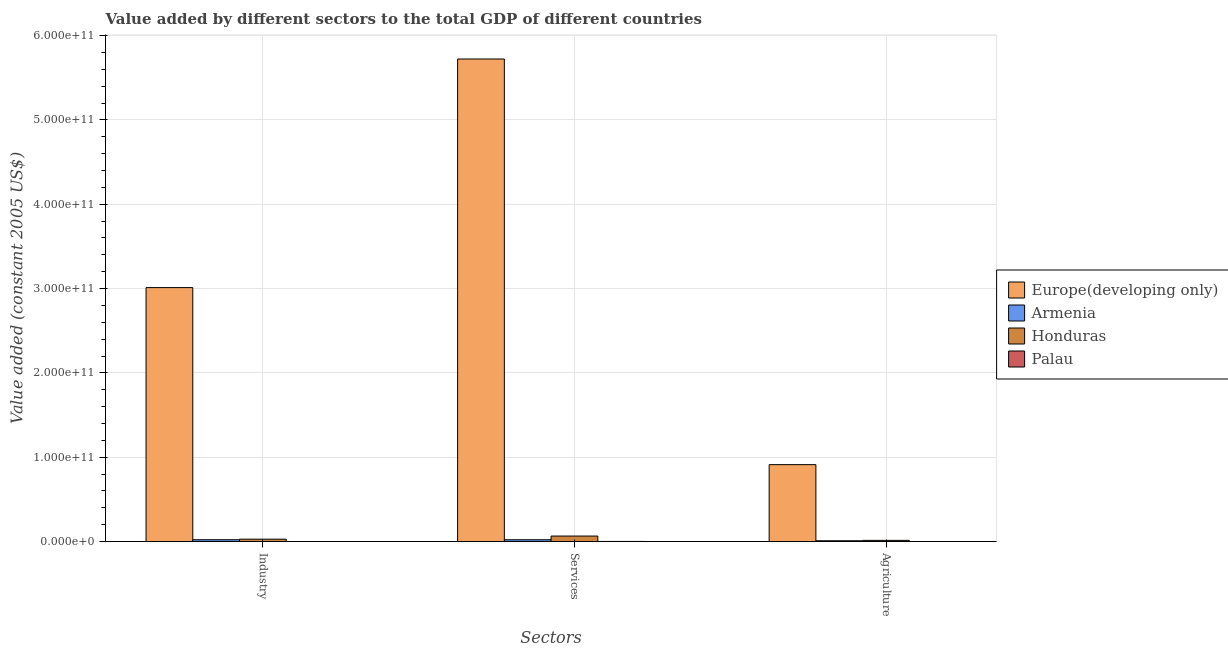How many different coloured bars are there?
Make the answer very short. 4. Are the number of bars on each tick of the X-axis equal?
Offer a very short reply. Yes. How many bars are there on the 2nd tick from the left?
Your answer should be compact. 4. What is the label of the 3rd group of bars from the left?
Your answer should be compact. Agriculture. What is the value added by agricultural sector in Europe(developing only)?
Provide a succinct answer. 9.12e+1. Across all countries, what is the maximum value added by services?
Your answer should be compact. 5.72e+11. Across all countries, what is the minimum value added by services?
Your response must be concise. 1.30e+08. In which country was the value added by services maximum?
Ensure brevity in your answer.  Europe(developing only). In which country was the value added by industrial sector minimum?
Your response must be concise. Palau. What is the total value added by agricultural sector in the graph?
Keep it short and to the point. 9.36e+1. What is the difference between the value added by agricultural sector in Armenia and that in Honduras?
Make the answer very short. -4.41e+08. What is the difference between the value added by agricultural sector in Europe(developing only) and the value added by services in Honduras?
Your answer should be compact. 8.47e+1. What is the average value added by agricultural sector per country?
Keep it short and to the point. 2.34e+1. What is the difference between the value added by services and value added by industrial sector in Honduras?
Give a very brief answer. 3.71e+09. In how many countries, is the value added by services greater than 80000000000 US$?
Provide a succinct answer. 1. What is the ratio of the value added by services in Honduras to that in Palau?
Provide a succinct answer. 50.4. Is the value added by agricultural sector in Armenia less than that in Palau?
Offer a terse response. No. Is the difference between the value added by industrial sector in Honduras and Palau greater than the difference between the value added by agricultural sector in Honduras and Palau?
Provide a short and direct response. Yes. What is the difference between the highest and the second highest value added by services?
Provide a succinct answer. 5.66e+11. What is the difference between the highest and the lowest value added by agricultural sector?
Your response must be concise. 9.12e+1. In how many countries, is the value added by industrial sector greater than the average value added by industrial sector taken over all countries?
Offer a very short reply. 1. What does the 3rd bar from the left in Industry represents?
Make the answer very short. Honduras. What does the 2nd bar from the right in Industry represents?
Your response must be concise. Honduras. Is it the case that in every country, the sum of the value added by industrial sector and value added by services is greater than the value added by agricultural sector?
Make the answer very short. Yes. Are all the bars in the graph horizontal?
Provide a succinct answer. No. How many countries are there in the graph?
Provide a succinct answer. 4. What is the difference between two consecutive major ticks on the Y-axis?
Ensure brevity in your answer.  1.00e+11. Are the values on the major ticks of Y-axis written in scientific E-notation?
Offer a terse response. Yes. Does the graph contain any zero values?
Provide a short and direct response. No. Where does the legend appear in the graph?
Make the answer very short. Center right. How many legend labels are there?
Ensure brevity in your answer.  4. How are the legend labels stacked?
Your answer should be compact. Vertical. What is the title of the graph?
Your answer should be very brief. Value added by different sectors to the total GDP of different countries. What is the label or title of the X-axis?
Ensure brevity in your answer.  Sectors. What is the label or title of the Y-axis?
Provide a short and direct response. Value added (constant 2005 US$). What is the Value added (constant 2005 US$) of Europe(developing only) in Industry?
Offer a very short reply. 3.01e+11. What is the Value added (constant 2005 US$) in Armenia in Industry?
Ensure brevity in your answer.  2.17e+09. What is the Value added (constant 2005 US$) of Honduras in Industry?
Your answer should be very brief. 2.83e+09. What is the Value added (constant 2005 US$) of Palau in Industry?
Give a very brief answer. 1.30e+07. What is the Value added (constant 2005 US$) of Europe(developing only) in Services?
Keep it short and to the point. 5.72e+11. What is the Value added (constant 2005 US$) in Armenia in Services?
Offer a terse response. 2.16e+09. What is the Value added (constant 2005 US$) of Honduras in Services?
Provide a succinct answer. 6.54e+09. What is the Value added (constant 2005 US$) of Palau in Services?
Offer a terse response. 1.30e+08. What is the Value added (constant 2005 US$) of Europe(developing only) in Agriculture?
Make the answer very short. 9.12e+1. What is the Value added (constant 2005 US$) in Armenia in Agriculture?
Make the answer very short. 9.52e+08. What is the Value added (constant 2005 US$) in Honduras in Agriculture?
Your response must be concise. 1.39e+09. What is the Value added (constant 2005 US$) of Palau in Agriculture?
Ensure brevity in your answer.  6.64e+06. Across all Sectors, what is the maximum Value added (constant 2005 US$) of Europe(developing only)?
Make the answer very short. 5.72e+11. Across all Sectors, what is the maximum Value added (constant 2005 US$) of Armenia?
Your answer should be very brief. 2.17e+09. Across all Sectors, what is the maximum Value added (constant 2005 US$) of Honduras?
Make the answer very short. 6.54e+09. Across all Sectors, what is the maximum Value added (constant 2005 US$) of Palau?
Ensure brevity in your answer.  1.30e+08. Across all Sectors, what is the minimum Value added (constant 2005 US$) of Europe(developing only)?
Your answer should be compact. 9.12e+1. Across all Sectors, what is the minimum Value added (constant 2005 US$) of Armenia?
Your response must be concise. 9.52e+08. Across all Sectors, what is the minimum Value added (constant 2005 US$) of Honduras?
Keep it short and to the point. 1.39e+09. Across all Sectors, what is the minimum Value added (constant 2005 US$) of Palau?
Provide a succinct answer. 6.64e+06. What is the total Value added (constant 2005 US$) in Europe(developing only) in the graph?
Keep it short and to the point. 9.65e+11. What is the total Value added (constant 2005 US$) in Armenia in the graph?
Provide a succinct answer. 5.29e+09. What is the total Value added (constant 2005 US$) of Honduras in the graph?
Your response must be concise. 1.08e+1. What is the total Value added (constant 2005 US$) of Palau in the graph?
Ensure brevity in your answer.  1.49e+08. What is the difference between the Value added (constant 2005 US$) in Europe(developing only) in Industry and that in Services?
Your answer should be very brief. -2.71e+11. What is the difference between the Value added (constant 2005 US$) of Armenia in Industry and that in Services?
Ensure brevity in your answer.  5.08e+06. What is the difference between the Value added (constant 2005 US$) of Honduras in Industry and that in Services?
Keep it short and to the point. -3.71e+09. What is the difference between the Value added (constant 2005 US$) in Palau in Industry and that in Services?
Provide a short and direct response. -1.17e+08. What is the difference between the Value added (constant 2005 US$) in Europe(developing only) in Industry and that in Agriculture?
Provide a short and direct response. 2.10e+11. What is the difference between the Value added (constant 2005 US$) in Armenia in Industry and that in Agriculture?
Provide a succinct answer. 1.22e+09. What is the difference between the Value added (constant 2005 US$) of Honduras in Industry and that in Agriculture?
Your answer should be very brief. 1.44e+09. What is the difference between the Value added (constant 2005 US$) of Palau in Industry and that in Agriculture?
Give a very brief answer. 6.33e+06. What is the difference between the Value added (constant 2005 US$) of Europe(developing only) in Services and that in Agriculture?
Make the answer very short. 4.81e+11. What is the difference between the Value added (constant 2005 US$) of Armenia in Services and that in Agriculture?
Keep it short and to the point. 1.21e+09. What is the difference between the Value added (constant 2005 US$) of Honduras in Services and that in Agriculture?
Provide a short and direct response. 5.15e+09. What is the difference between the Value added (constant 2005 US$) of Palau in Services and that in Agriculture?
Keep it short and to the point. 1.23e+08. What is the difference between the Value added (constant 2005 US$) in Europe(developing only) in Industry and the Value added (constant 2005 US$) in Armenia in Services?
Offer a very short reply. 2.99e+11. What is the difference between the Value added (constant 2005 US$) in Europe(developing only) in Industry and the Value added (constant 2005 US$) in Honduras in Services?
Keep it short and to the point. 2.95e+11. What is the difference between the Value added (constant 2005 US$) of Europe(developing only) in Industry and the Value added (constant 2005 US$) of Palau in Services?
Offer a very short reply. 3.01e+11. What is the difference between the Value added (constant 2005 US$) in Armenia in Industry and the Value added (constant 2005 US$) in Honduras in Services?
Your answer should be very brief. -4.37e+09. What is the difference between the Value added (constant 2005 US$) in Armenia in Industry and the Value added (constant 2005 US$) in Palau in Services?
Offer a terse response. 2.04e+09. What is the difference between the Value added (constant 2005 US$) in Honduras in Industry and the Value added (constant 2005 US$) in Palau in Services?
Keep it short and to the point. 2.70e+09. What is the difference between the Value added (constant 2005 US$) of Europe(developing only) in Industry and the Value added (constant 2005 US$) of Armenia in Agriculture?
Keep it short and to the point. 3.00e+11. What is the difference between the Value added (constant 2005 US$) of Europe(developing only) in Industry and the Value added (constant 2005 US$) of Honduras in Agriculture?
Make the answer very short. 3.00e+11. What is the difference between the Value added (constant 2005 US$) in Europe(developing only) in Industry and the Value added (constant 2005 US$) in Palau in Agriculture?
Your response must be concise. 3.01e+11. What is the difference between the Value added (constant 2005 US$) in Armenia in Industry and the Value added (constant 2005 US$) in Honduras in Agriculture?
Your answer should be very brief. 7.77e+08. What is the difference between the Value added (constant 2005 US$) of Armenia in Industry and the Value added (constant 2005 US$) of Palau in Agriculture?
Your answer should be compact. 2.16e+09. What is the difference between the Value added (constant 2005 US$) in Honduras in Industry and the Value added (constant 2005 US$) in Palau in Agriculture?
Your answer should be very brief. 2.82e+09. What is the difference between the Value added (constant 2005 US$) of Europe(developing only) in Services and the Value added (constant 2005 US$) of Armenia in Agriculture?
Your answer should be very brief. 5.71e+11. What is the difference between the Value added (constant 2005 US$) in Europe(developing only) in Services and the Value added (constant 2005 US$) in Honduras in Agriculture?
Your answer should be very brief. 5.71e+11. What is the difference between the Value added (constant 2005 US$) in Europe(developing only) in Services and the Value added (constant 2005 US$) in Palau in Agriculture?
Ensure brevity in your answer.  5.72e+11. What is the difference between the Value added (constant 2005 US$) in Armenia in Services and the Value added (constant 2005 US$) in Honduras in Agriculture?
Provide a succinct answer. 7.72e+08. What is the difference between the Value added (constant 2005 US$) of Armenia in Services and the Value added (constant 2005 US$) of Palau in Agriculture?
Your response must be concise. 2.16e+09. What is the difference between the Value added (constant 2005 US$) of Honduras in Services and the Value added (constant 2005 US$) of Palau in Agriculture?
Ensure brevity in your answer.  6.53e+09. What is the average Value added (constant 2005 US$) in Europe(developing only) per Sectors?
Provide a succinct answer. 3.22e+11. What is the average Value added (constant 2005 US$) in Armenia per Sectors?
Provide a short and direct response. 1.76e+09. What is the average Value added (constant 2005 US$) in Honduras per Sectors?
Keep it short and to the point. 3.59e+09. What is the average Value added (constant 2005 US$) in Palau per Sectors?
Ensure brevity in your answer.  4.98e+07. What is the difference between the Value added (constant 2005 US$) in Europe(developing only) and Value added (constant 2005 US$) in Armenia in Industry?
Keep it short and to the point. 2.99e+11. What is the difference between the Value added (constant 2005 US$) in Europe(developing only) and Value added (constant 2005 US$) in Honduras in Industry?
Keep it short and to the point. 2.98e+11. What is the difference between the Value added (constant 2005 US$) of Europe(developing only) and Value added (constant 2005 US$) of Palau in Industry?
Offer a very short reply. 3.01e+11. What is the difference between the Value added (constant 2005 US$) in Armenia and Value added (constant 2005 US$) in Honduras in Industry?
Your answer should be very brief. -6.62e+08. What is the difference between the Value added (constant 2005 US$) of Armenia and Value added (constant 2005 US$) of Palau in Industry?
Keep it short and to the point. 2.16e+09. What is the difference between the Value added (constant 2005 US$) of Honduras and Value added (constant 2005 US$) of Palau in Industry?
Offer a terse response. 2.82e+09. What is the difference between the Value added (constant 2005 US$) in Europe(developing only) and Value added (constant 2005 US$) in Armenia in Services?
Give a very brief answer. 5.70e+11. What is the difference between the Value added (constant 2005 US$) in Europe(developing only) and Value added (constant 2005 US$) in Honduras in Services?
Your answer should be very brief. 5.66e+11. What is the difference between the Value added (constant 2005 US$) of Europe(developing only) and Value added (constant 2005 US$) of Palau in Services?
Provide a short and direct response. 5.72e+11. What is the difference between the Value added (constant 2005 US$) of Armenia and Value added (constant 2005 US$) of Honduras in Services?
Your answer should be very brief. -4.37e+09. What is the difference between the Value added (constant 2005 US$) in Armenia and Value added (constant 2005 US$) in Palau in Services?
Your answer should be very brief. 2.03e+09. What is the difference between the Value added (constant 2005 US$) in Honduras and Value added (constant 2005 US$) in Palau in Services?
Keep it short and to the point. 6.41e+09. What is the difference between the Value added (constant 2005 US$) of Europe(developing only) and Value added (constant 2005 US$) of Armenia in Agriculture?
Give a very brief answer. 9.03e+1. What is the difference between the Value added (constant 2005 US$) in Europe(developing only) and Value added (constant 2005 US$) in Honduras in Agriculture?
Provide a short and direct response. 8.98e+1. What is the difference between the Value added (constant 2005 US$) in Europe(developing only) and Value added (constant 2005 US$) in Palau in Agriculture?
Ensure brevity in your answer.  9.12e+1. What is the difference between the Value added (constant 2005 US$) of Armenia and Value added (constant 2005 US$) of Honduras in Agriculture?
Offer a very short reply. -4.41e+08. What is the difference between the Value added (constant 2005 US$) in Armenia and Value added (constant 2005 US$) in Palau in Agriculture?
Your response must be concise. 9.45e+08. What is the difference between the Value added (constant 2005 US$) of Honduras and Value added (constant 2005 US$) of Palau in Agriculture?
Offer a terse response. 1.39e+09. What is the ratio of the Value added (constant 2005 US$) of Europe(developing only) in Industry to that in Services?
Offer a very short reply. 0.53. What is the ratio of the Value added (constant 2005 US$) of Armenia in Industry to that in Services?
Ensure brevity in your answer.  1. What is the ratio of the Value added (constant 2005 US$) of Honduras in Industry to that in Services?
Your answer should be very brief. 0.43. What is the ratio of the Value added (constant 2005 US$) of Europe(developing only) in Industry to that in Agriculture?
Offer a terse response. 3.3. What is the ratio of the Value added (constant 2005 US$) in Armenia in Industry to that in Agriculture?
Your response must be concise. 2.28. What is the ratio of the Value added (constant 2005 US$) of Honduras in Industry to that in Agriculture?
Your answer should be very brief. 2.03. What is the ratio of the Value added (constant 2005 US$) of Palau in Industry to that in Agriculture?
Provide a short and direct response. 1.95. What is the ratio of the Value added (constant 2005 US$) in Europe(developing only) in Services to that in Agriculture?
Your response must be concise. 6.27. What is the ratio of the Value added (constant 2005 US$) in Armenia in Services to that in Agriculture?
Give a very brief answer. 2.27. What is the ratio of the Value added (constant 2005 US$) of Honduras in Services to that in Agriculture?
Make the answer very short. 4.69. What is the ratio of the Value added (constant 2005 US$) in Palau in Services to that in Agriculture?
Make the answer very short. 19.53. What is the difference between the highest and the second highest Value added (constant 2005 US$) in Europe(developing only)?
Ensure brevity in your answer.  2.71e+11. What is the difference between the highest and the second highest Value added (constant 2005 US$) in Armenia?
Offer a terse response. 5.08e+06. What is the difference between the highest and the second highest Value added (constant 2005 US$) in Honduras?
Your answer should be compact. 3.71e+09. What is the difference between the highest and the second highest Value added (constant 2005 US$) in Palau?
Offer a terse response. 1.17e+08. What is the difference between the highest and the lowest Value added (constant 2005 US$) in Europe(developing only)?
Offer a terse response. 4.81e+11. What is the difference between the highest and the lowest Value added (constant 2005 US$) in Armenia?
Your answer should be very brief. 1.22e+09. What is the difference between the highest and the lowest Value added (constant 2005 US$) in Honduras?
Your response must be concise. 5.15e+09. What is the difference between the highest and the lowest Value added (constant 2005 US$) in Palau?
Offer a very short reply. 1.23e+08. 